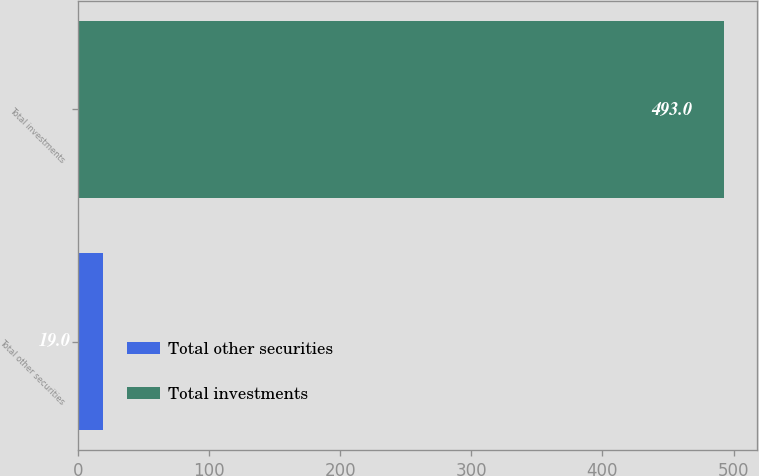Convert chart to OTSL. <chart><loc_0><loc_0><loc_500><loc_500><bar_chart><fcel>Total other securities<fcel>Total investments<nl><fcel>19<fcel>493<nl></chart> 